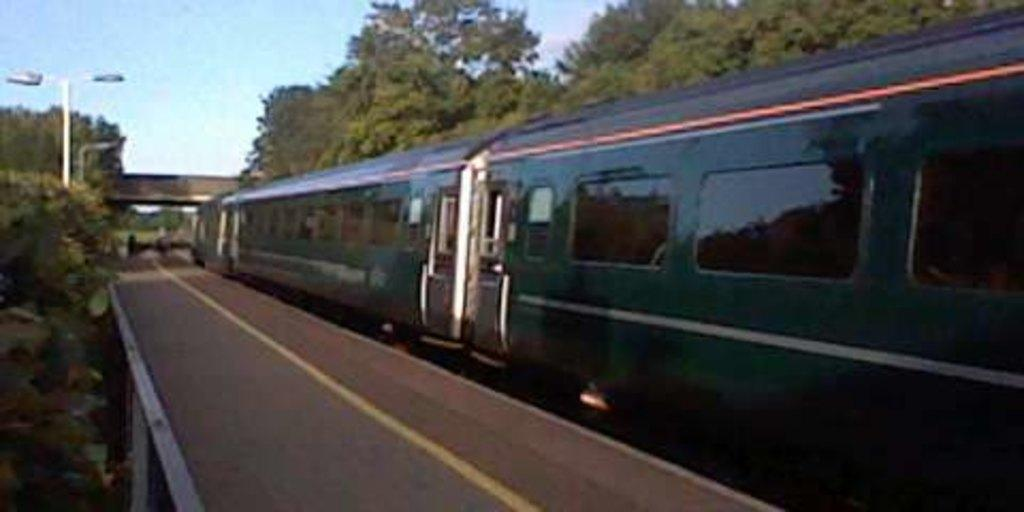What is the main subject of the image? The main subject of the image is a train. What can be seen on the train in the image? There are glass windows and doors visible on the train in the image. What is present near the train in the image? There is a platform, trees, poles, and a bridge present near the train in the image. What is visible in the background of the image? The sky is visible in the background of the image. Where is the scarecrow standing in the image? There is no scarecrow present in the image. What type of lead is being used to connect the train to the tracks in the image? The image does not show any details about the connection between the train and the tracks, so it is not possible to determine the type of lead being used. 